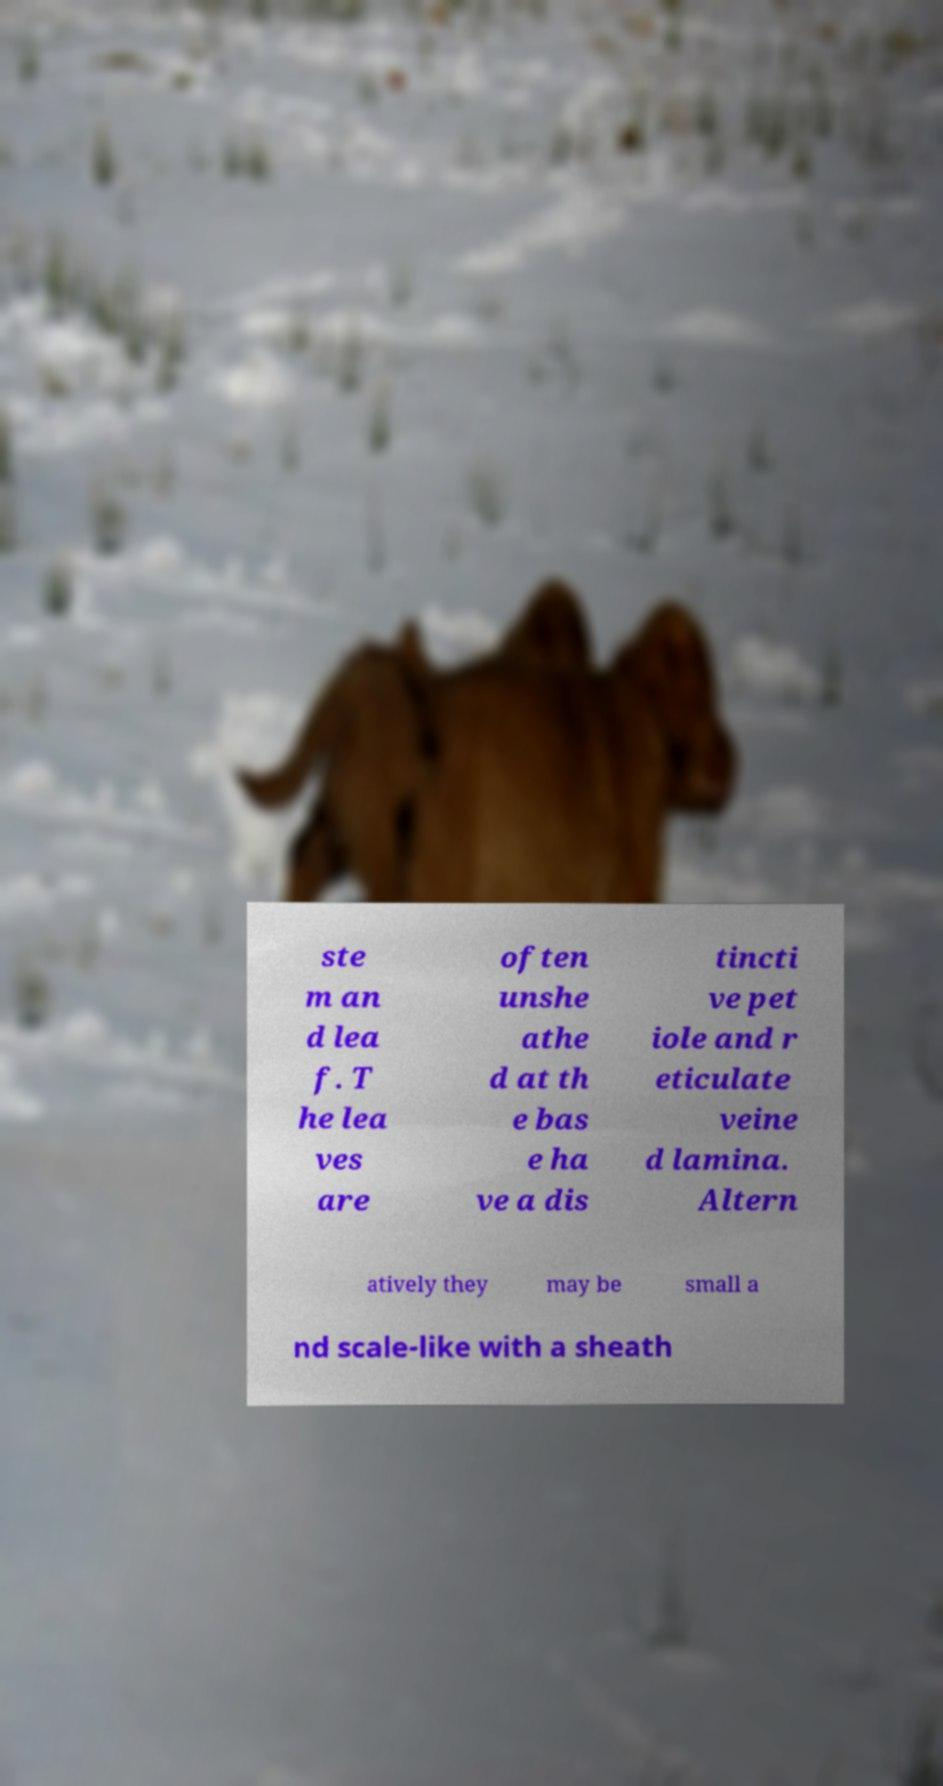Please read and relay the text visible in this image. What does it say? ste m an d lea f. T he lea ves are often unshe athe d at th e bas e ha ve a dis tincti ve pet iole and r eticulate veine d lamina. Altern atively they may be small a nd scale-like with a sheath 